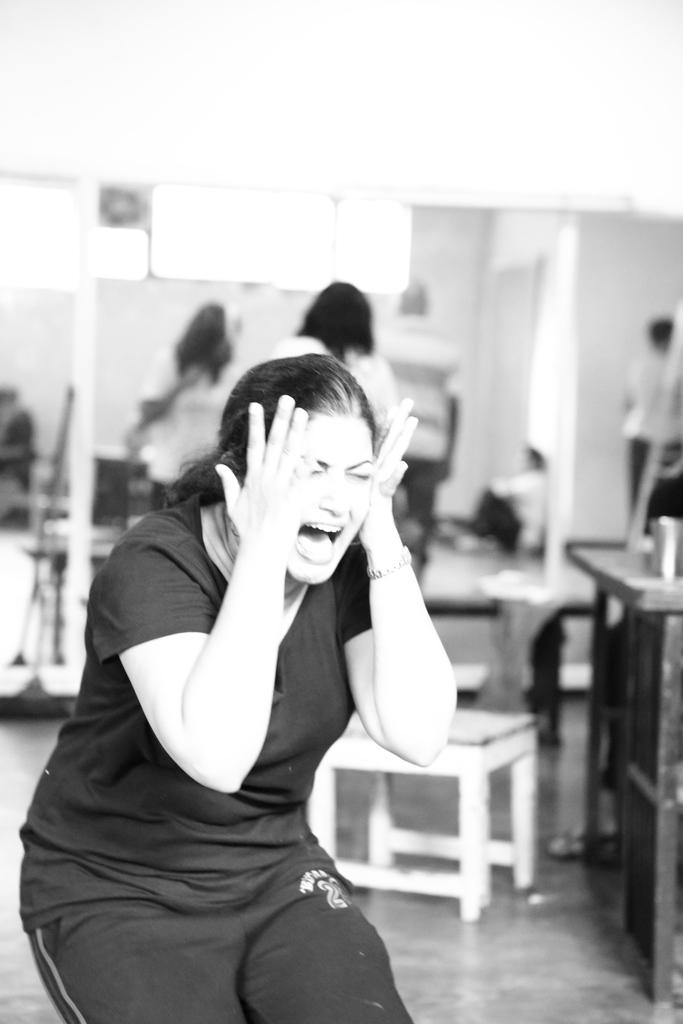What is the person in the image wearing? The person in the image is wearing a shirt. What object is located beside the person? There is a chair beside the person. Are there any other people visible in the image? Yes, there are people standing behind the person. What is the position of the person sitting in the image? There is a person sitting on the floor. What type of alarm is the potato sounding in the image? There is no potato or alarm present in the image. 